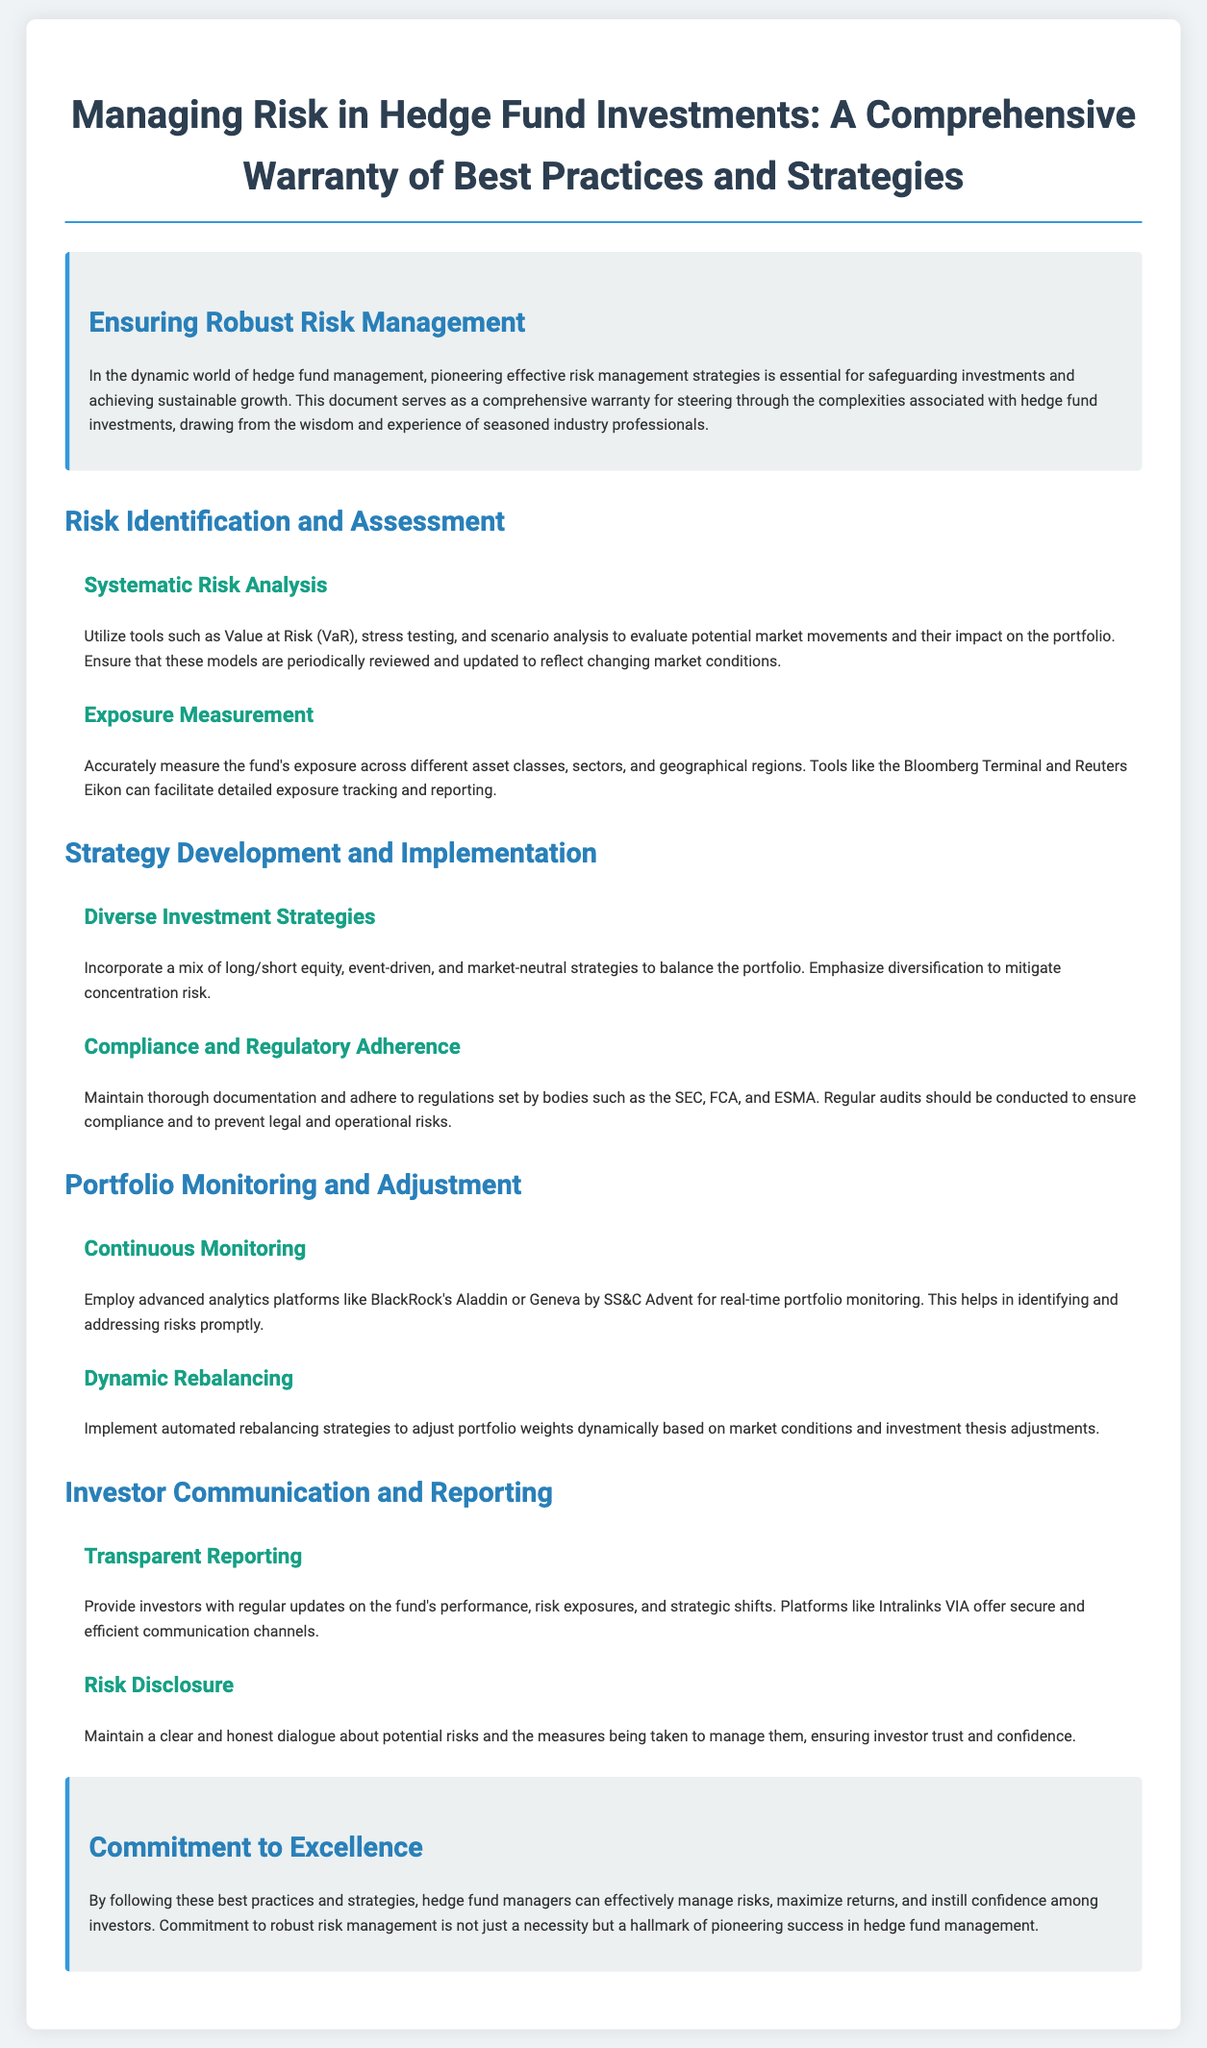What is the title of the document? The title is presented at the top of the document, stating the main theme of the content.
Answer: Managing Risk in Hedge Fund Investments: A Comprehensive Warranty of Best Practices and Strategies What tool is suggested for systematic risk analysis? The document recommends utilizing specific tools to conduct risk analysis effectively.
Answer: Value at Risk (VaR) What strategy is emphasized for portfolio diversity? The document discusses the incorporation of various strategies to manage concentration risk.
Answer: Long/short equity, event-driven, and market-neutral strategies Which platforms are mentioned for real-time portfolio monitoring? The document names specific analytics platforms beneficial for monitoring investments.
Answer: BlackRock's Aladdin or Geneva by SS&C Advent What is the primary focus of the conclusion section? The final section resolves the discussions in the document and reiterates the importance of a particular aspect.
Answer: Commitment to robust risk management 